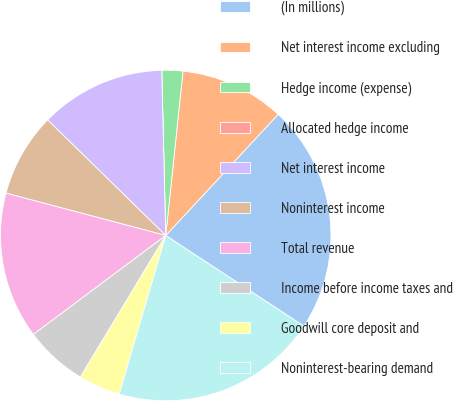Convert chart. <chart><loc_0><loc_0><loc_500><loc_500><pie_chart><fcel>(In millions)<fcel>Net interest income excluding<fcel>Hedge income (expense)<fcel>Allocated hedge income<fcel>Net interest income<fcel>Noninterest income<fcel>Total revenue<fcel>Income before income taxes and<fcel>Goodwill core deposit and<fcel>Noninterest-bearing demand<nl><fcel>22.34%<fcel>10.24%<fcel>2.05%<fcel>0.0%<fcel>12.29%<fcel>8.2%<fcel>14.34%<fcel>6.15%<fcel>4.1%<fcel>20.29%<nl></chart> 